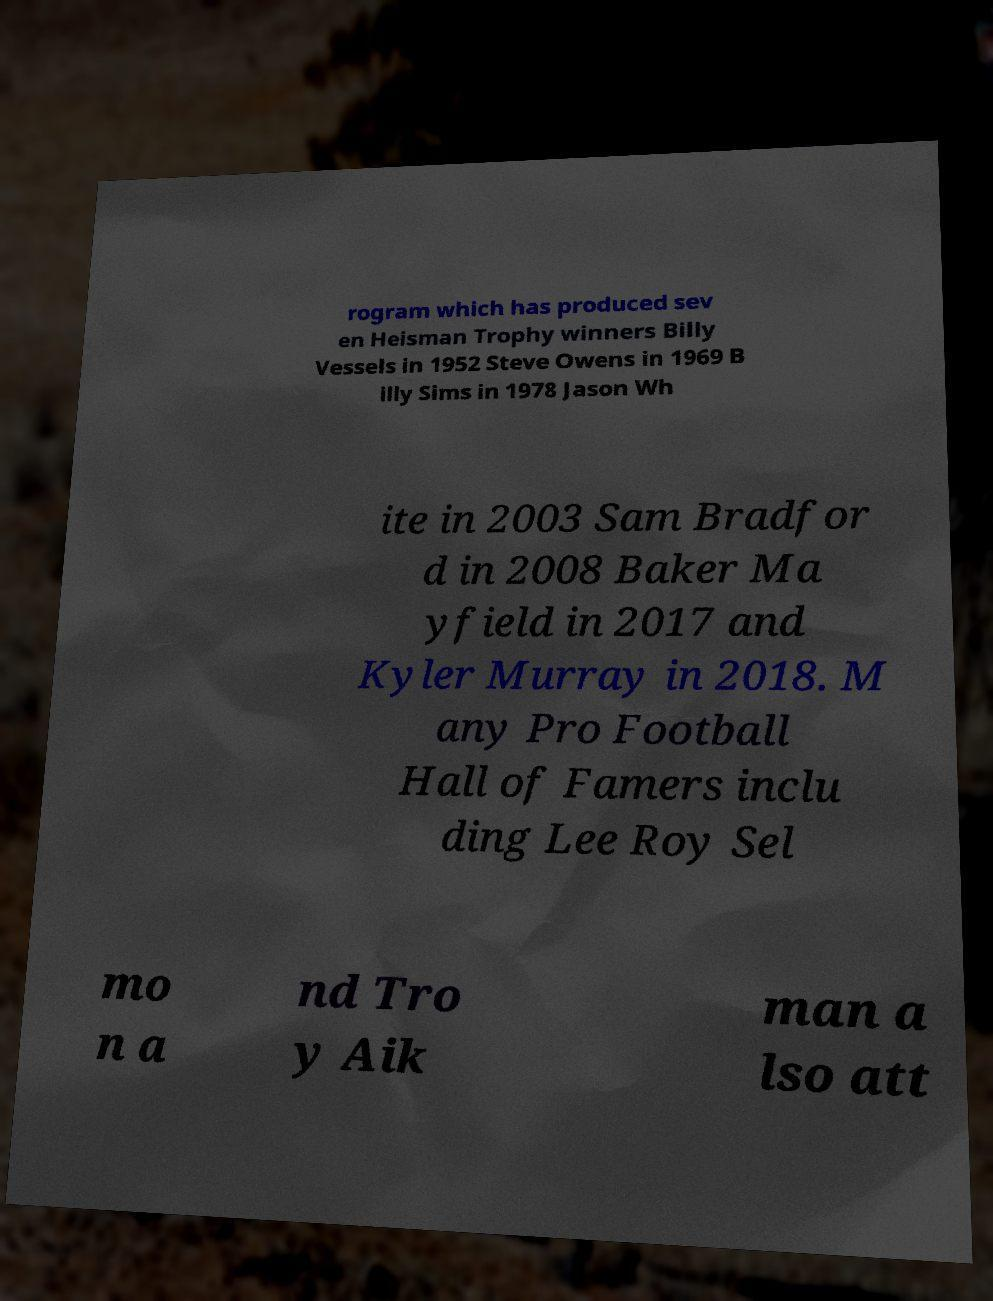There's text embedded in this image that I need extracted. Can you transcribe it verbatim? rogram which has produced sev en Heisman Trophy winners Billy Vessels in 1952 Steve Owens in 1969 B illy Sims in 1978 Jason Wh ite in 2003 Sam Bradfor d in 2008 Baker Ma yfield in 2017 and Kyler Murray in 2018. M any Pro Football Hall of Famers inclu ding Lee Roy Sel mo n a nd Tro y Aik man a lso att 